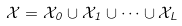Convert formula to latex. <formula><loc_0><loc_0><loc_500><loc_500>\mathcal { X } = \mathcal { X } _ { 0 } \cup \mathcal { X } _ { 1 } \cup \cdots \cup \mathcal { X } _ { L }</formula> 